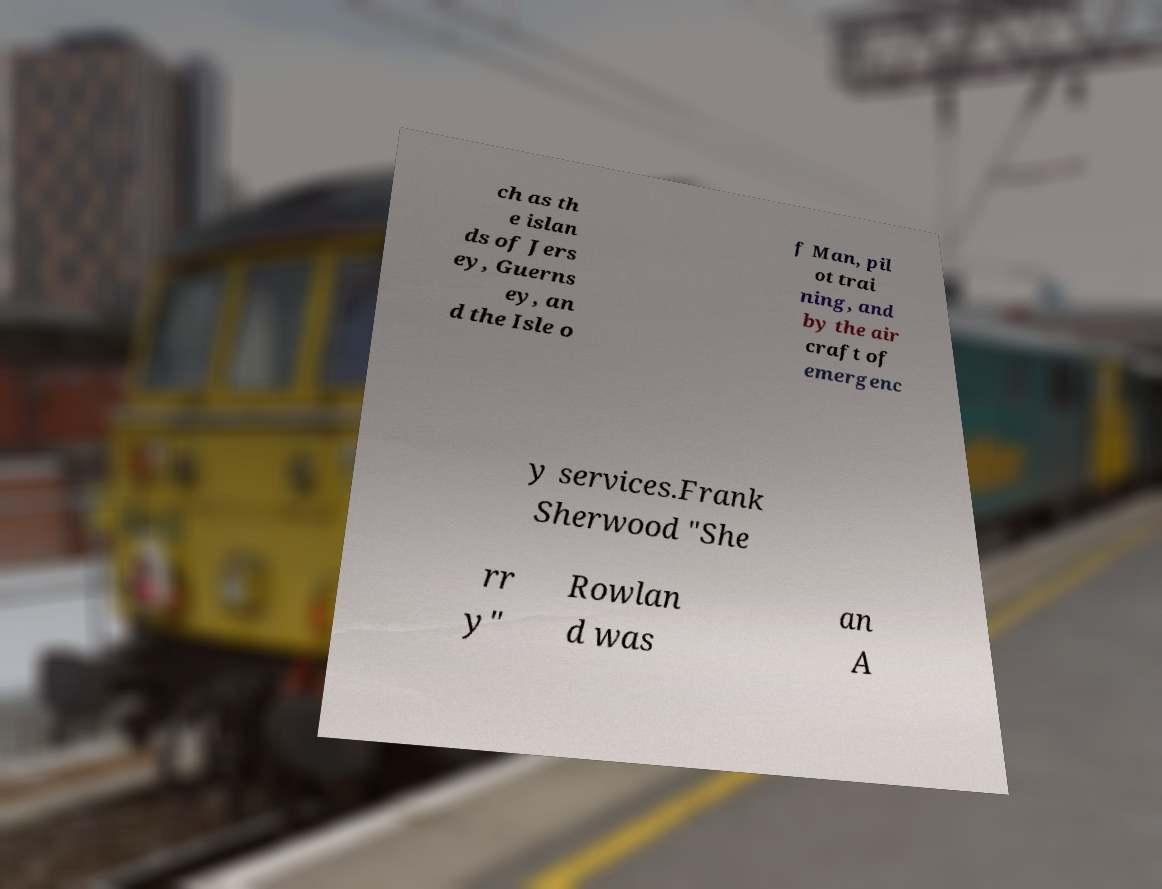For documentation purposes, I need the text within this image transcribed. Could you provide that? ch as th e islan ds of Jers ey, Guerns ey, an d the Isle o f Man, pil ot trai ning, and by the air craft of emergenc y services.Frank Sherwood "She rr y" Rowlan d was an A 